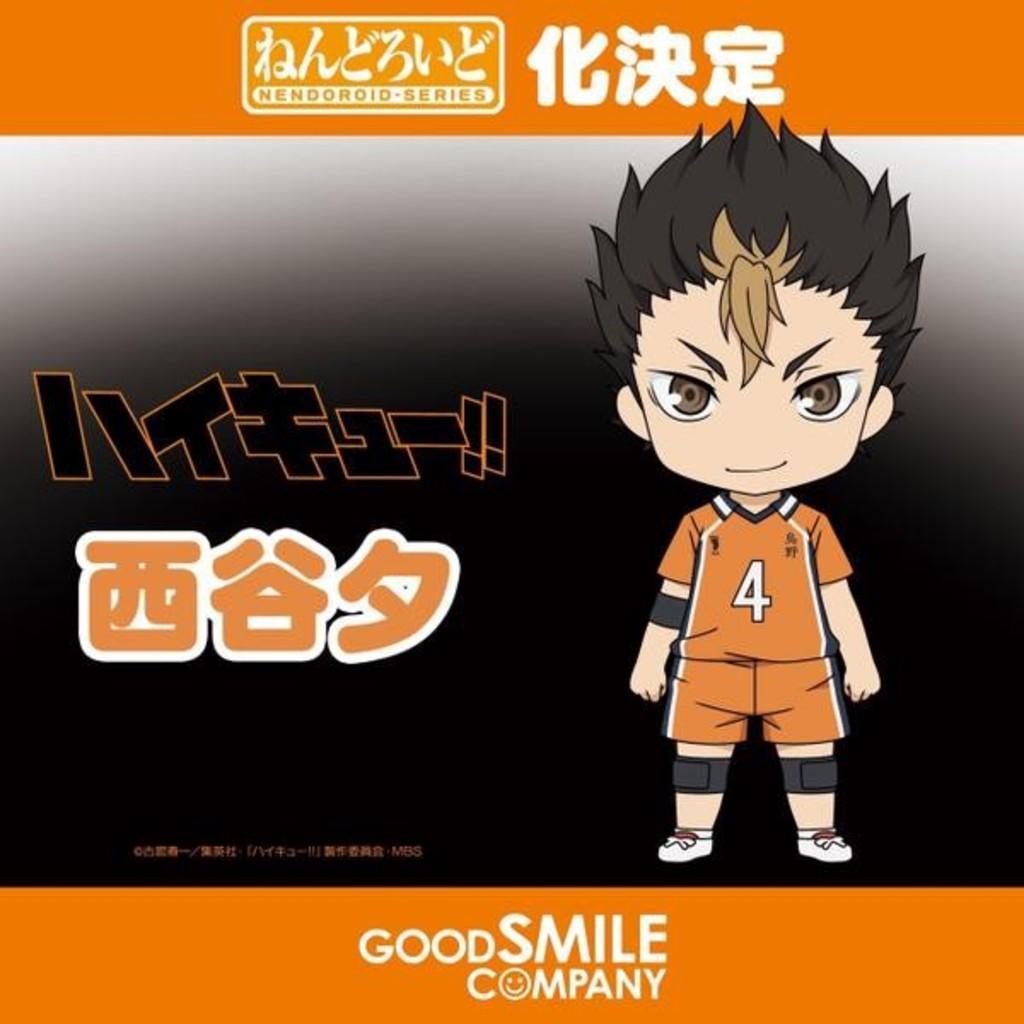Describe this image in one or two sentences. In the image there is a poster. On the right side of the image there is an animated image of a boy. And also there is a number on the dress. And there is something written on the poster. 